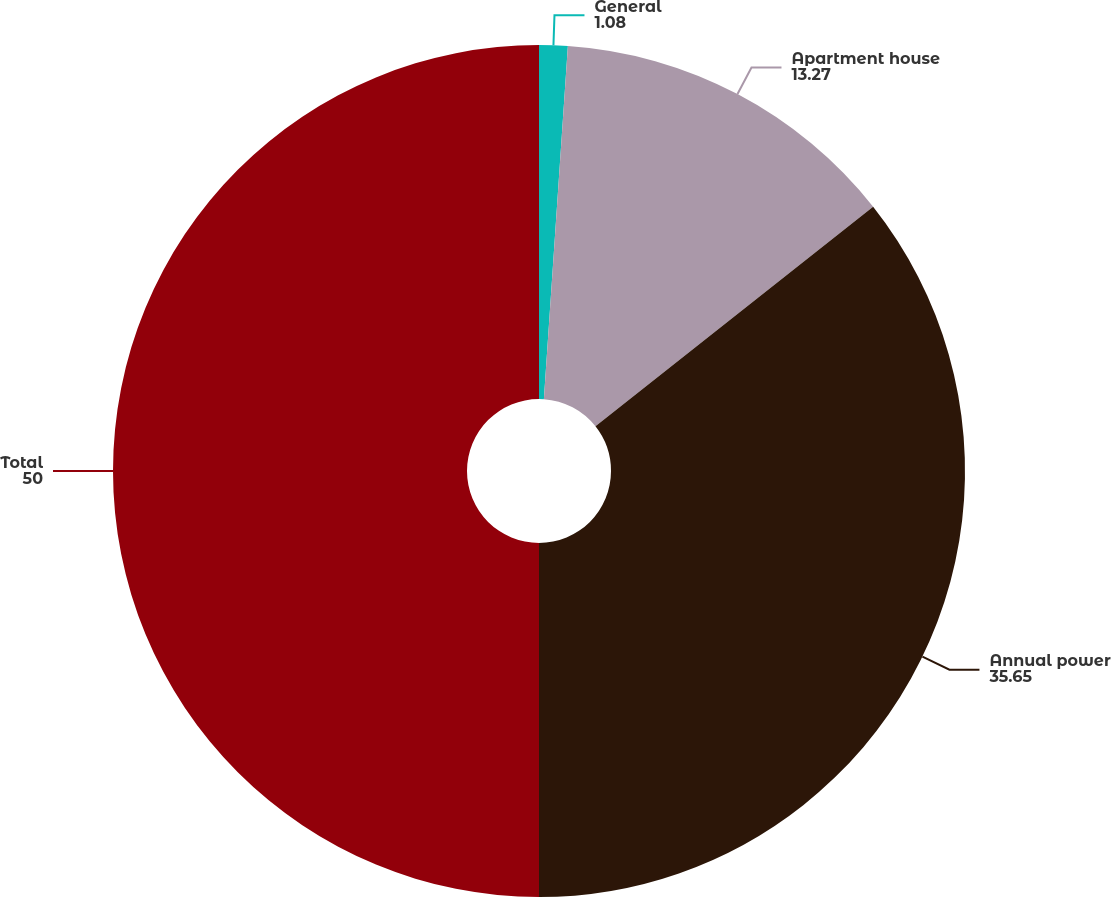Convert chart to OTSL. <chart><loc_0><loc_0><loc_500><loc_500><pie_chart><fcel>General<fcel>Apartment house<fcel>Annual power<fcel>Total<nl><fcel>1.08%<fcel>13.27%<fcel>35.65%<fcel>50.0%<nl></chart> 